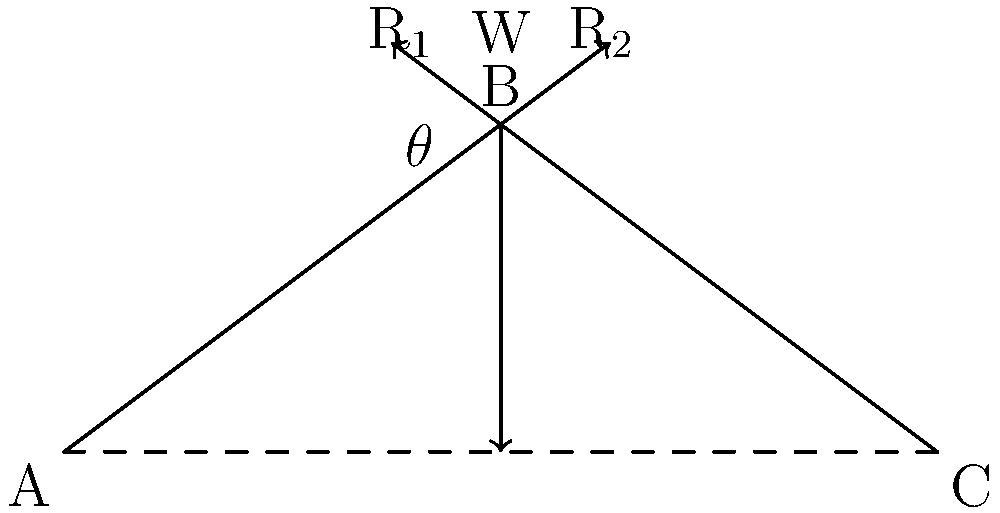In the stone arch of a medieval village church, as shown in the force diagram, what is the relationship between the vertical load W and the horizontal thrust H at the supports, given that the angle between the line of thrust and the horizontal at the support is $\theta$? To determine the relationship between the vertical load W and the horizontal thrust H, we need to analyze the forces acting on the arch:

1. The vertical load W acts downward at the crown of the arch.
2. The reactions at the supports can be resolved into horizontal (H) and vertical (V) components.

3. For equilibrium, the sum of vertical forces must equal zero:
   $$W = 2V$$

4. The angle $\theta$ is formed between the resultant force R and the horizontal at the support.

5. Using trigonometry, we can express the relationship between H and V:
   $$\tan \theta = \frac{V}{H}$$

6. Rearranging this equation:
   $$V = H \tan \theta$$

7. Substituting this into the vertical equilibrium equation:
   $$W = 2H \tan \theta$$

8. Solving for H:
   $$H = \frac{W}{2\tan \theta}$$

This equation shows the relationship between the vertical load W and the horizontal thrust H, taking into account the angle of the line of thrust at the supports.
Answer: $H = \frac{W}{2\tan \theta}$ 